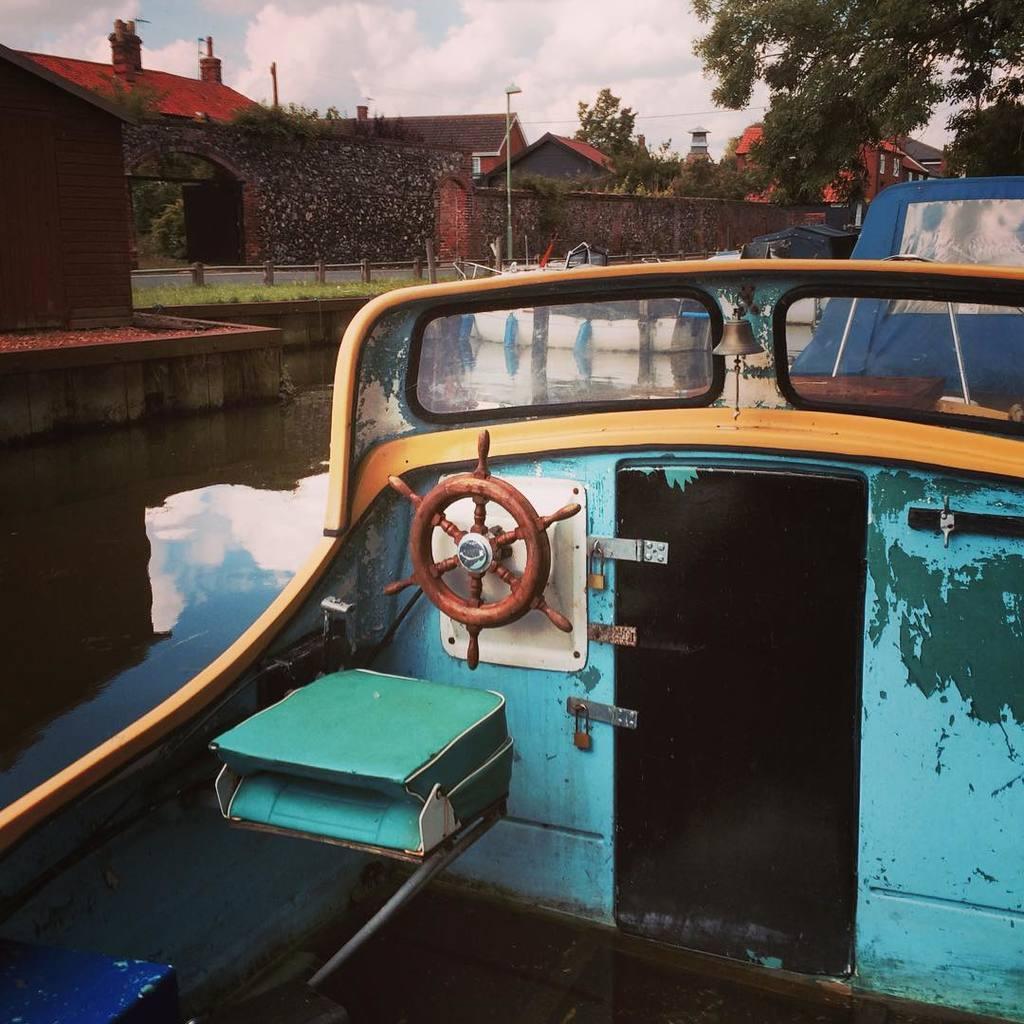Please provide a concise description of this image. In this image I can see a boat which is in green color and the boat is on the water, background I can see few buildings in brown color, trees in green color and the sky is in white and blue color. 